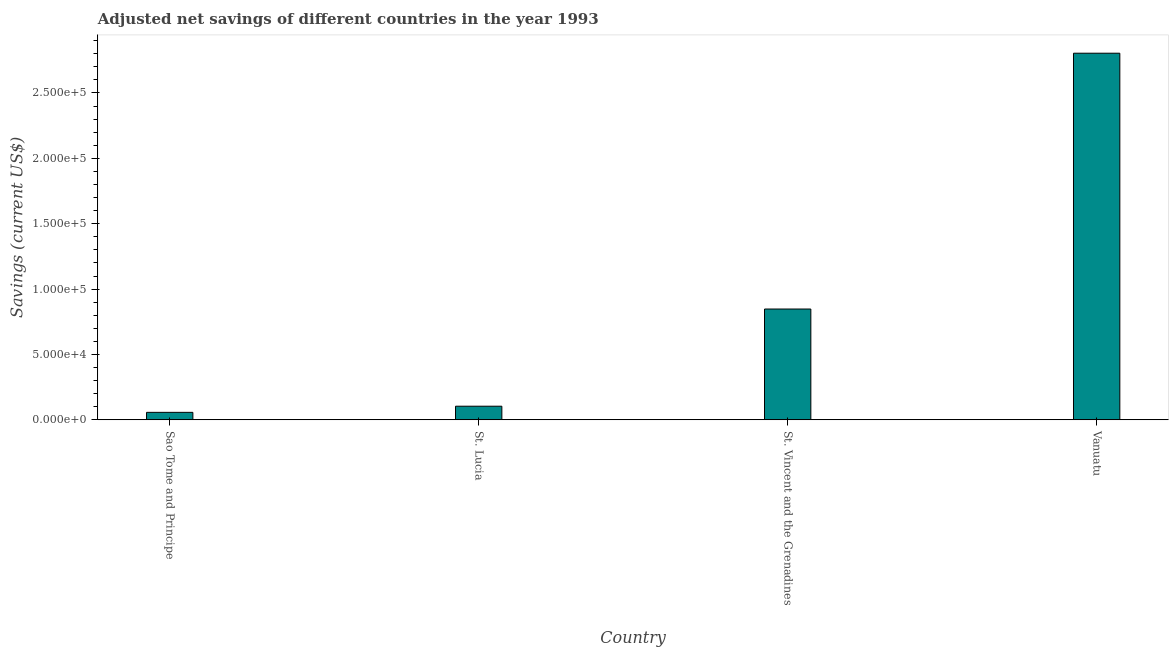Does the graph contain any zero values?
Keep it short and to the point. No. What is the title of the graph?
Keep it short and to the point. Adjusted net savings of different countries in the year 1993. What is the label or title of the X-axis?
Provide a succinct answer. Country. What is the label or title of the Y-axis?
Offer a very short reply. Savings (current US$). What is the adjusted net savings in Sao Tome and Principe?
Give a very brief answer. 5698.23. Across all countries, what is the maximum adjusted net savings?
Your answer should be very brief. 2.80e+05. Across all countries, what is the minimum adjusted net savings?
Make the answer very short. 5698.23. In which country was the adjusted net savings maximum?
Your answer should be very brief. Vanuatu. In which country was the adjusted net savings minimum?
Your response must be concise. Sao Tome and Principe. What is the sum of the adjusted net savings?
Ensure brevity in your answer.  3.81e+05. What is the difference between the adjusted net savings in St. Lucia and Vanuatu?
Ensure brevity in your answer.  -2.70e+05. What is the average adjusted net savings per country?
Provide a short and direct response. 9.53e+04. What is the median adjusted net savings?
Your response must be concise. 4.76e+04. What is the ratio of the adjusted net savings in St. Lucia to that in Vanuatu?
Your answer should be compact. 0.04. Is the difference between the adjusted net savings in St. Lucia and Vanuatu greater than the difference between any two countries?
Offer a terse response. No. What is the difference between the highest and the second highest adjusted net savings?
Your answer should be very brief. 1.96e+05. What is the difference between the highest and the lowest adjusted net savings?
Your answer should be compact. 2.75e+05. In how many countries, is the adjusted net savings greater than the average adjusted net savings taken over all countries?
Make the answer very short. 1. How many bars are there?
Keep it short and to the point. 4. How many countries are there in the graph?
Give a very brief answer. 4. What is the difference between two consecutive major ticks on the Y-axis?
Your response must be concise. 5.00e+04. What is the Savings (current US$) of Sao Tome and Principe?
Make the answer very short. 5698.23. What is the Savings (current US$) of St. Lucia?
Ensure brevity in your answer.  1.04e+04. What is the Savings (current US$) in St. Vincent and the Grenadines?
Offer a very short reply. 8.47e+04. What is the Savings (current US$) of Vanuatu?
Your answer should be very brief. 2.80e+05. What is the difference between the Savings (current US$) in Sao Tome and Principe and St. Lucia?
Provide a succinct answer. -4706.27. What is the difference between the Savings (current US$) in Sao Tome and Principe and St. Vincent and the Grenadines?
Ensure brevity in your answer.  -7.90e+04. What is the difference between the Savings (current US$) in Sao Tome and Principe and Vanuatu?
Your answer should be very brief. -2.75e+05. What is the difference between the Savings (current US$) in St. Lucia and St. Vincent and the Grenadines?
Your response must be concise. -7.43e+04. What is the difference between the Savings (current US$) in St. Lucia and Vanuatu?
Ensure brevity in your answer.  -2.70e+05. What is the difference between the Savings (current US$) in St. Vincent and the Grenadines and Vanuatu?
Give a very brief answer. -1.96e+05. What is the ratio of the Savings (current US$) in Sao Tome and Principe to that in St. Lucia?
Make the answer very short. 0.55. What is the ratio of the Savings (current US$) in Sao Tome and Principe to that in St. Vincent and the Grenadines?
Make the answer very short. 0.07. What is the ratio of the Savings (current US$) in St. Lucia to that in St. Vincent and the Grenadines?
Keep it short and to the point. 0.12. What is the ratio of the Savings (current US$) in St. Lucia to that in Vanuatu?
Provide a short and direct response. 0.04. What is the ratio of the Savings (current US$) in St. Vincent and the Grenadines to that in Vanuatu?
Make the answer very short. 0.3. 